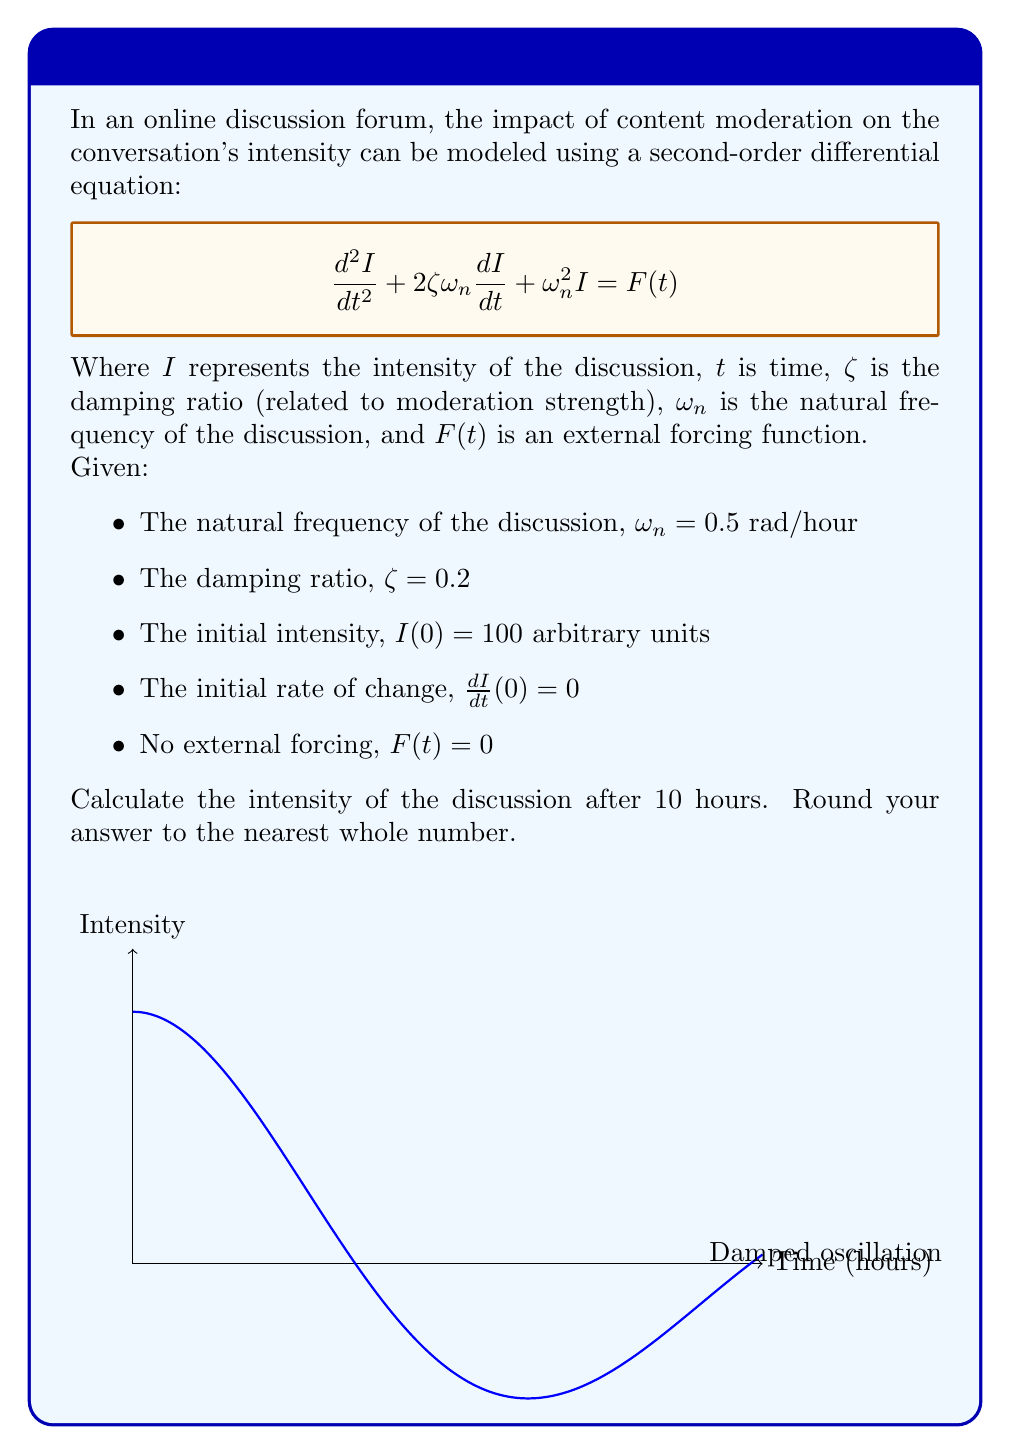Can you answer this question? To solve this problem, we'll follow these steps:

1) The general solution for this second-order differential equation with no forcing term is:

   $$I(t) = A e^{-\zeta\omega_n t} \cos(\omega_d t) + B e^{-\zeta\omega_n t} \sin(\omega_d t)$$

   where $\omega_d = \omega_n \sqrt{1-\zeta^2}$ is the damped natural frequency.

2) Calculate $\omega_d$:
   $$\omega_d = 0.5 \sqrt{1-0.2^2} = 0.4899 \text{ rad/hour}$$

3) Use the initial conditions to find A and B:
   - $I(0) = 100 = A$
   - $\frac{dI}{dt}(0) = 0 = -\zeta\omega_n A + \omega_d B$
     $0 = -0.2 * 0.5 * 100 + 0.4899B$
     $B = 20.41$

4) Substitute these values into the general solution:
   $$I(t) = 100 e^{-0.1t} \cos(0.4899t) + 20.41 e^{-0.1t} \sin(0.4899t)$$

5) Calculate the intensity at t = 10 hours:
   $$I(10) = 100 e^{-1} \cos(4.899) + 20.41 e^{-1} \sin(4.899)$$
   $$I(10) = 36.79 * (-0.9647) + 7.51 * 0.2633$$
   $$I(10) = -35.49 + 1.98 = -33.51$$

6) Round to the nearest whole number:
   $I(10) \approx -34$

The negative value indicates that the discussion has reversed polarity, which could be interpreted as a shift in the discussion's direction or sentiment.
Answer: -34 